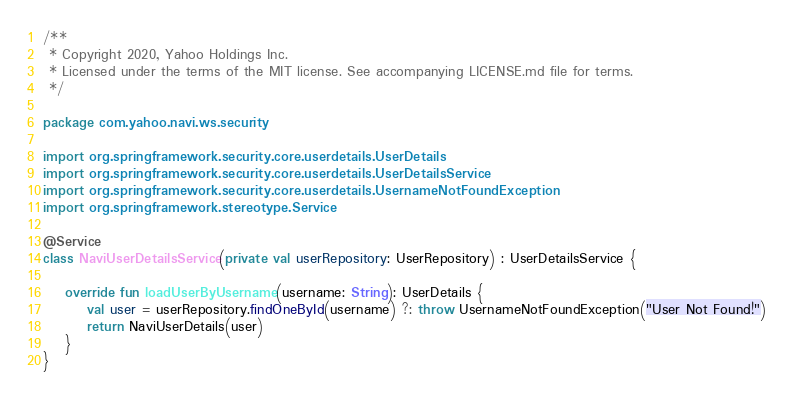<code> <loc_0><loc_0><loc_500><loc_500><_Kotlin_>/**
 * Copyright 2020, Yahoo Holdings Inc.
 * Licensed under the terms of the MIT license. See accompanying LICENSE.md file for terms.
 */

package com.yahoo.navi.ws.security

import org.springframework.security.core.userdetails.UserDetails
import org.springframework.security.core.userdetails.UserDetailsService
import org.springframework.security.core.userdetails.UsernameNotFoundException
import org.springframework.stereotype.Service

@Service
class NaviUserDetailsService(private val userRepository: UserRepository) : UserDetailsService {

    override fun loadUserByUsername(username: String): UserDetails {
        val user = userRepository.findOneById(username) ?: throw UsernameNotFoundException("User Not Found!")
        return NaviUserDetails(user)
    }
}
</code> 